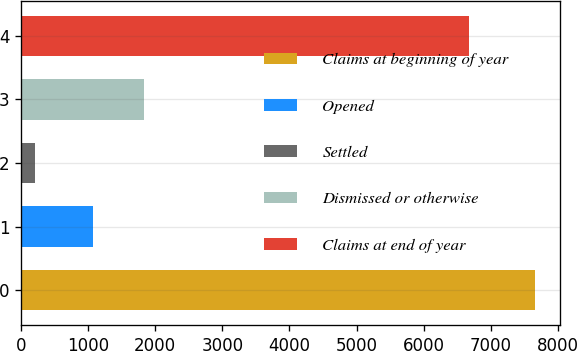Convert chart to OTSL. <chart><loc_0><loc_0><loc_500><loc_500><bar_chart><fcel>Claims at beginning of year<fcel>Opened<fcel>Settled<fcel>Dismissed or otherwise<fcel>Claims at end of year<nl><fcel>7652<fcel>1065<fcel>207<fcel>1836<fcel>6674<nl></chart> 